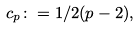Convert formula to latex. <formula><loc_0><loc_0><loc_500><loc_500>c _ { p } \colon = 1 / 2 ( p - 2 ) ,</formula> 